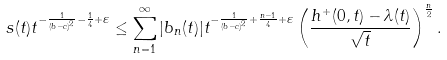<formula> <loc_0><loc_0><loc_500><loc_500>s ( t ) t ^ { - \frac { 1 } { ( b - c ) ^ { 2 } } - \frac { 1 } { 4 } + \varepsilon } \leq \sum _ { n = 1 } ^ { \infty } | b _ { n } ( t ) | t ^ { - \frac { 1 } { ( b - c ) ^ { 2 } } + \frac { n - 1 } { 4 } + \varepsilon } \left ( \frac { h ^ { + } ( 0 , t ) - \lambda ( t ) } { \sqrt { t } } \right ) ^ { \frac { n } { 2 } } .</formula> 